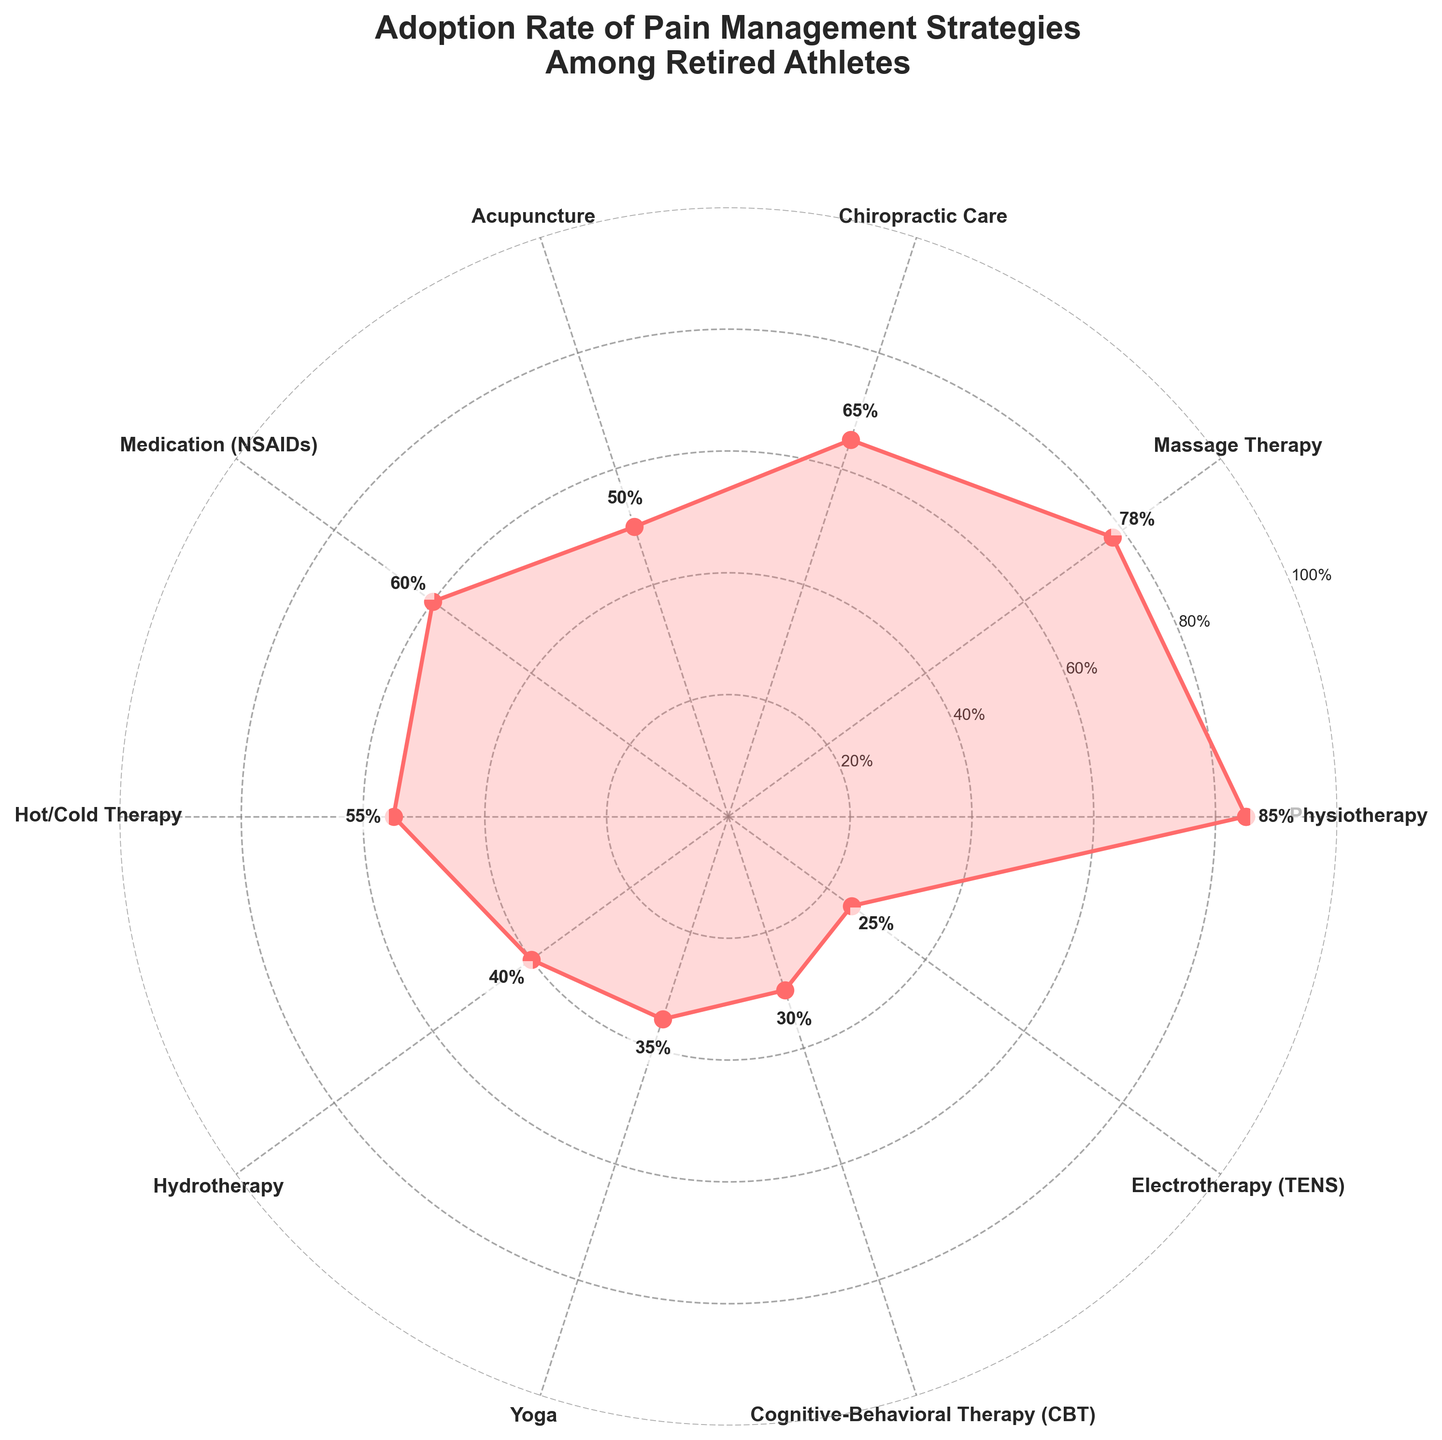What is the title of the polar chart? The title is located at the top of the chart and reads "Adoption Rate of Pain Management Strategies Among Retired Athletes"
Answer: Adoption Rate of Pain Management Strategies Among Retired Athletes How many pain management strategies are shown in the chart? By counting the labels around the circle, we see there are ten different pain management strategies
Answer: 10 Which pain management strategy has the highest adoption rate? Physiotherapy has the highest value marked in the chart, with an adoption rate of 85%
Answer: Physiotherapy What is the adoption rate of Electrotherapy (TENS)? By locating the label "Electrotherapy (TENS)" on the chart, we find the value marked near it as 25%
Answer: 25% Which strategy is less adopted: Yoga or Hot/Cold Therapy? Comparing the rates near the labels "Yoga" and "Hot/Cold Therapy," Yoga has a lower adoption rate at 35%, compared to Hot/Cold Therapy at 55%
Answer: Yoga What's the difference in adoption rates between Massage Therapy and Medication (NSAIDs)? Massage Therapy has an adoption rate of 78%, and Medication (NSAIDs) has a rate of 60%; their difference is 78% - 60% = 18%
Answer: 18% What is the average adoption rate of Physiotherapy, Massage Therapy, and Chiropractic Care? Adding their rates (85% + 78% + 65%) gives 228%; dividing by 3 gives an average of 228% / 3 = 76%
Answer: 76% Which strategies have adoption rates above 50%? By looking at the chart, we find Physiotherapy, Massage Therapy, Chiropractic Care, Medication (NSAIDs), and Hot/Cold Therapy all have rates above 50%
Answer: Physiotherapy, Massage Therapy, Chiropractic Care, Medication (NSAIDs), Hot/Cold Therapy Is Cognitive-Behavioral Therapy (CBT) more or less adopted than Hydrotherapy? The rate for Cognitive-Behavioral Therapy (CBT) is 30%, while Hydrotherapy is 40%, making CBT less adopted
Answer: Less What percentage of strategies listed have an adoption rate of 50% or higher? Five strategies have rates of 50% or higher out of ten total strategies, giving a percentage of (5/10) * 100% = 50%
Answer: 50% 